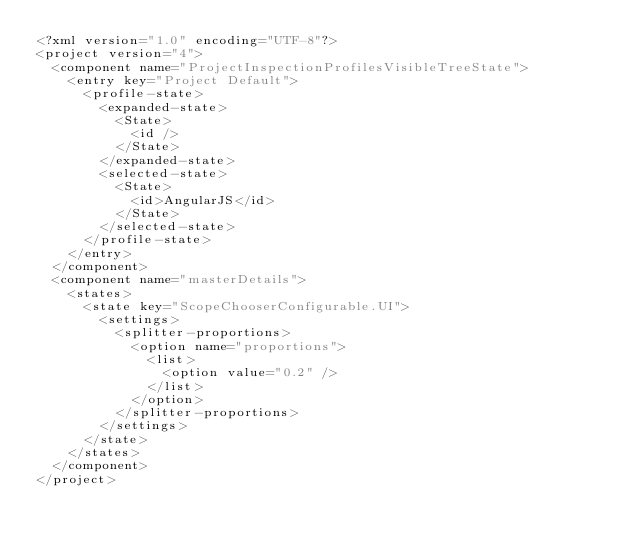<code> <loc_0><loc_0><loc_500><loc_500><_XML_><?xml version="1.0" encoding="UTF-8"?>
<project version="4">
  <component name="ProjectInspectionProfilesVisibleTreeState">
    <entry key="Project Default">
      <profile-state>
        <expanded-state>
          <State>
            <id />
          </State>
        </expanded-state>
        <selected-state>
          <State>
            <id>AngularJS</id>
          </State>
        </selected-state>
      </profile-state>
    </entry>
  </component>
  <component name="masterDetails">
    <states>
      <state key="ScopeChooserConfigurable.UI">
        <settings>
          <splitter-proportions>
            <option name="proportions">
              <list>
                <option value="0.2" />
              </list>
            </option>
          </splitter-proportions>
        </settings>
      </state>
    </states>
  </component>
</project></code> 